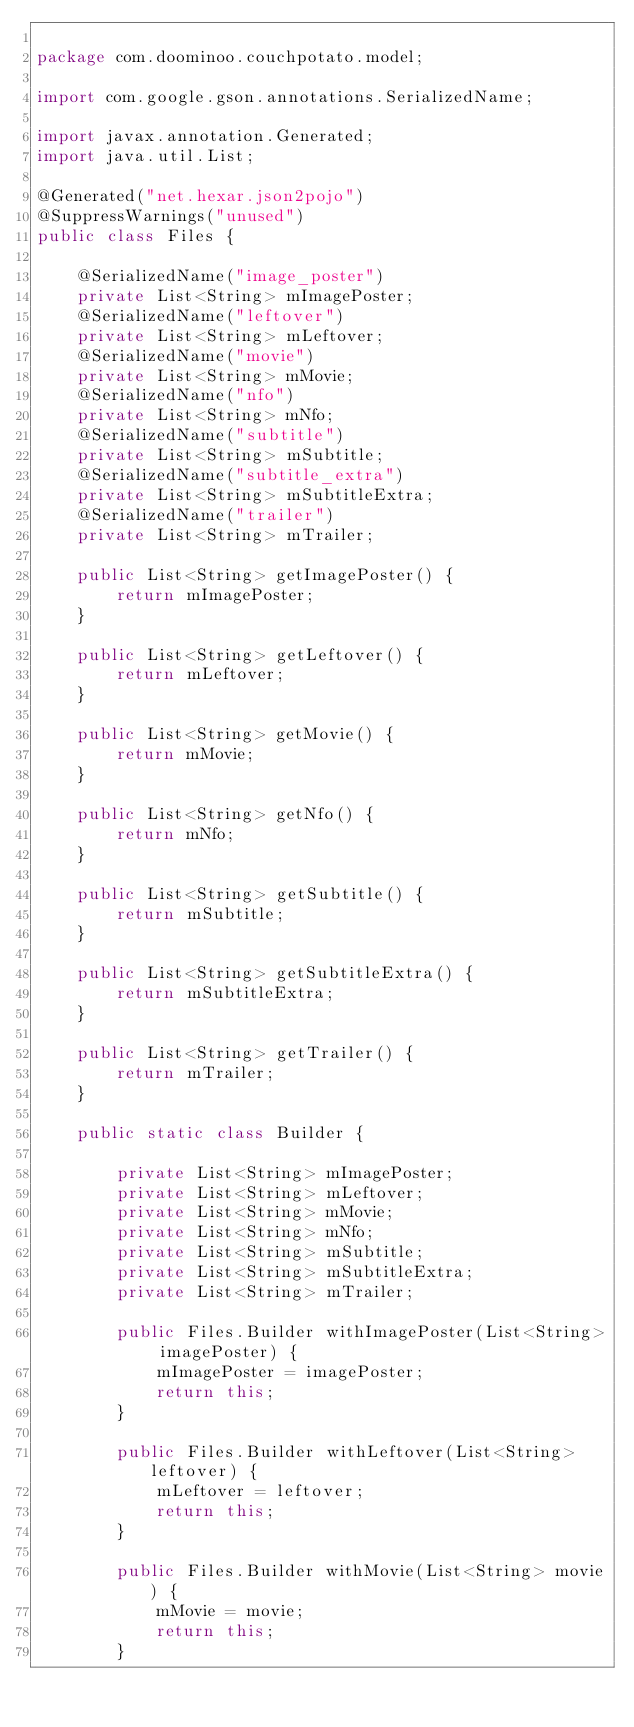<code> <loc_0><loc_0><loc_500><loc_500><_Java_>
package com.doominoo.couchpotato.model;

import com.google.gson.annotations.SerializedName;

import javax.annotation.Generated;
import java.util.List;

@Generated("net.hexar.json2pojo")
@SuppressWarnings("unused")
public class Files {

    @SerializedName("image_poster")
    private List<String> mImagePoster;
    @SerializedName("leftover")
    private List<String> mLeftover;
    @SerializedName("movie")
    private List<String> mMovie;
    @SerializedName("nfo")
    private List<String> mNfo;
    @SerializedName("subtitle")
    private List<String> mSubtitle;
    @SerializedName("subtitle_extra")
    private List<String> mSubtitleExtra;
    @SerializedName("trailer")
    private List<String> mTrailer;

    public List<String> getImagePoster() {
        return mImagePoster;
    }

    public List<String> getLeftover() {
        return mLeftover;
    }

    public List<String> getMovie() {
        return mMovie;
    }

    public List<String> getNfo() {
        return mNfo;
    }

    public List<String> getSubtitle() {
        return mSubtitle;
    }

    public List<String> getSubtitleExtra() {
        return mSubtitleExtra;
    }

    public List<String> getTrailer() {
        return mTrailer;
    }

    public static class Builder {

        private List<String> mImagePoster;
        private List<String> mLeftover;
        private List<String> mMovie;
        private List<String> mNfo;
        private List<String> mSubtitle;
        private List<String> mSubtitleExtra;
        private List<String> mTrailer;

        public Files.Builder withImagePoster(List<String> imagePoster) {
            mImagePoster = imagePoster;
            return this;
        }

        public Files.Builder withLeftover(List<String> leftover) {
            mLeftover = leftover;
            return this;
        }

        public Files.Builder withMovie(List<String> movie) {
            mMovie = movie;
            return this;
        }
</code> 